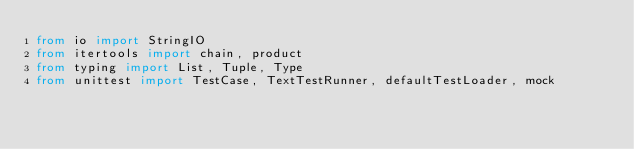<code> <loc_0><loc_0><loc_500><loc_500><_Python_>from io import StringIO
from itertools import chain, product
from typing import List, Tuple, Type
from unittest import TestCase, TextTestRunner, defaultTestLoader, mock
</code> 